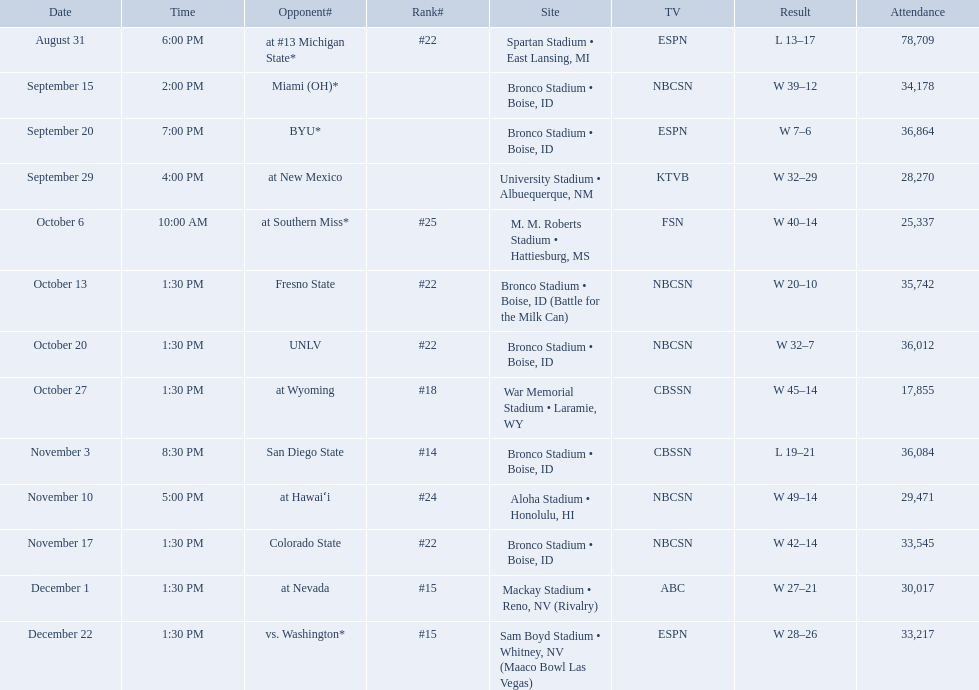What was the team's listed rankings for the season? #22, , , , #25, #22, #22, #18, #14, #24, #22, #15, #15. Which of these ranks is the best? #14. What are the opponent teams of the 2012 boise state broncos football team? At #13 michigan state*, miami (oh)*, byu*, at new mexico, at southern miss*, fresno state, unlv, at wyoming, san diego state, at hawaiʻi, colorado state, at nevada, vs. washington*. How has the highest rank of these opponents? San Diego State. What are the opponents to the  2012 boise state broncos football team? At #13 michigan state*, miami (oh)*, byu*, at new mexico, at southern miss*, fresno state, unlv, at wyoming, san diego state, at hawaiʻi, colorado state, at nevada, vs. washington*. Which is the highest ranked of the teams? San Diego State. Who are the rivals of the 2012 boise state broncos football team? At #13 michigan state*, miami (oh)*, byu*, at new mexico, at southern miss*, fresno state, unlv, at wyoming, san diego state, at hawaiʻi, colorado state, at nevada, vs. washington*. Which is the most esteemed of the teams? San Diego State. What are all the classifications? #22, , , , #25, #22, #22, #18, #14, #24, #22, #15, #15. Which among them was the most favorable placement? #14. What were the team's rankings throughout the season? #22, , , , #25, #22, #22, #18, #14, #24, #22, #15, #15. Which rank is considered the best? #14. What are the complete rankings? #22, , , , #25, #22, #22, #18, #14, #24, #22, #15, #15. Which one held the highest position? #14. Can you list all the competitors? At #13 michigan state*, miami (oh)*, byu*, at new mexico, at southern miss*, fresno state, unlv, at wyoming, san diego state, at hawaiʻi, colorado state, at nevada, vs. washington*. Who did they compete against on november 3rd? San Diego State. What was their ranking on november 3rd? #14. Who were all the rival participants? At #13 michigan state*, miami (oh)*, byu*, at new mexico, at southern miss*, fresno state, unlv, at wyoming, san diego state, at hawaiʻi, colorado state, at nevada, vs. washington*. Who were their matchups on november 3rd? San Diego State. What standing did they have on november 3rd? #14. Can you list all of boise state's opponents? At #13 michigan state*, miami (oh)*, byu*, at new mexico, at southern miss*, fresno state, unlv, at wyoming, san diego state, at hawaiʻi, colorado state, at nevada, vs. washington*. Which of these opponents had a ranking? At #13 michigan state*, #22, at southern miss*, #25, fresno state, #22, unlv, #22, at wyoming, #18, san diego state, #14. Which one among them was ranked the highest? San Diego State. 